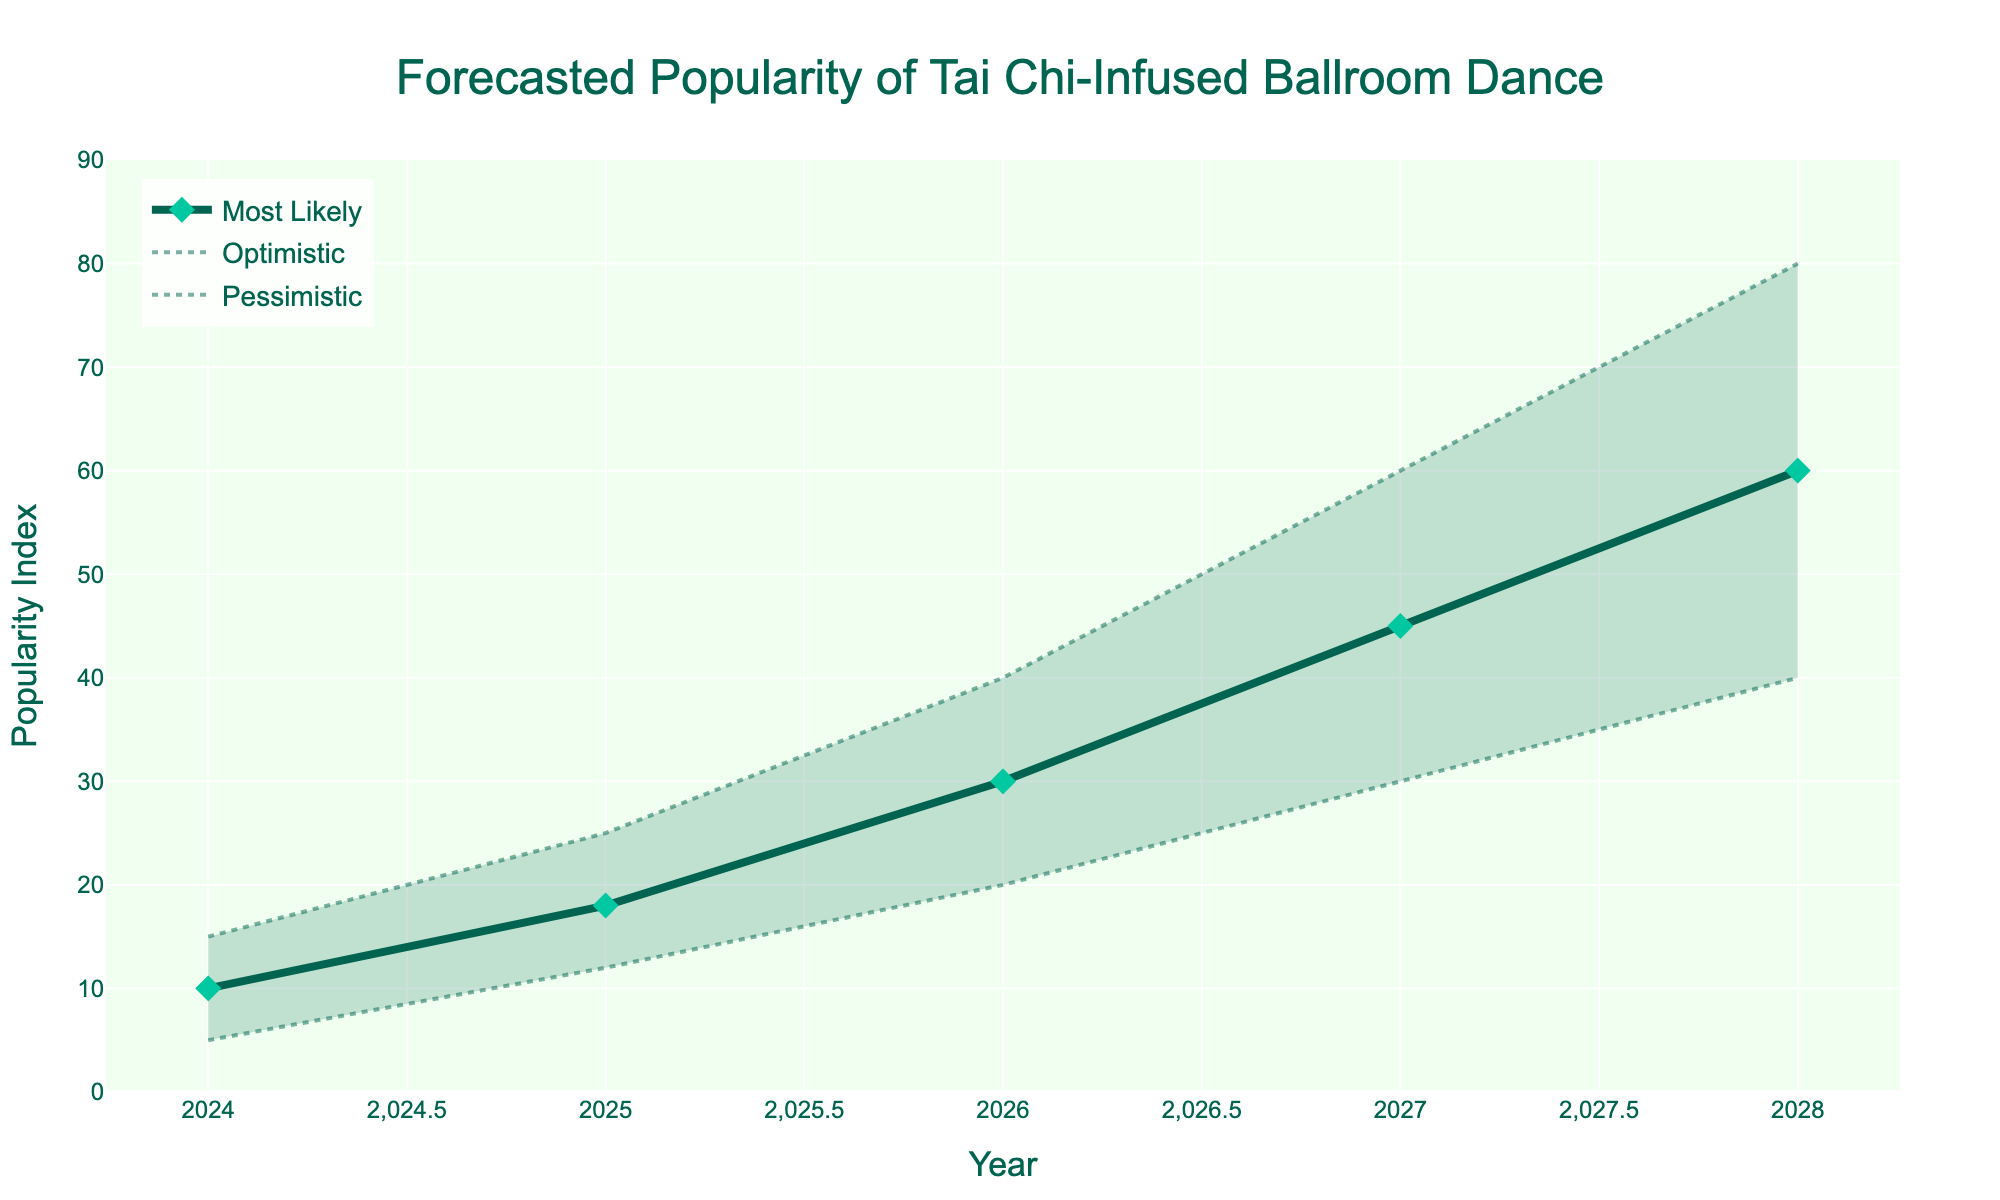What is the title of the figure? The title of the figure is written at the top center of the chart.
Answer: "Forecasted Popularity of Tai Chi-Infused Ballroom Dance" How many different trend lines are shown in the figure? By visually inspecting, there are three distinct trend lines – one for each scenario: Optimistic, Most Likely, and Pessimistic.
Answer: 3 What is the forecasted optimistic popularity index for 2028? Look at the optimistic trend line (highlighted with dots) and find the corresponding value for the year 2028.
Answer: 80 How does the most likely popularity index in 2025 compare to the pessimistic popularity index in 2027? Check the most likely index in 2025, which is 18, and compare it to the pessimistic index in 2027, which is 30.
Answer: The most likely index in 2025 is less than the pessimistic index in 2027 What is the average of the most likely popularity indices for the years presented? Add up the most likely values: 10, 18, 30, 45, and 60. Then, divide by the number of years (5). Average = (10 + 18 + 30 + 45 + 60) / 5.
Answer: 32.6 What is the range of the forecasted optimistic popularity index? Subtract the lowest optimistic value (2024: 15) from the highest optimistic value (2028: 80). Range = 80 - 15.
Answer: 65 Between which years is the growth in the most likely trend the steepest? Calculate the difference for each year: 18-10, 30-18, 45-30, 60-45. The largest difference is between 2027 and 2028 (45 to 60).
Answer: 2027-2028 How does the fan chart visually show uncertainty in the forecasts? The shaded area between optimistic and pessimistic trend lines indicates the uncertainty range around the most likely forecast.
Answer: Shaded area indicates uncertainty What is the optimistic prediction pattern over the 5 years? Check the values: 15, 25, 40, 60, 80. Identify the pattern: the values are increasing progressively every year.
Answer: Increasing values each year By what percentage is the forecasted most likely index expected to increase from 2026 to 2028? Calculate the percentage increase: (60-30) / 30 * 100%.
Answer: 100% 